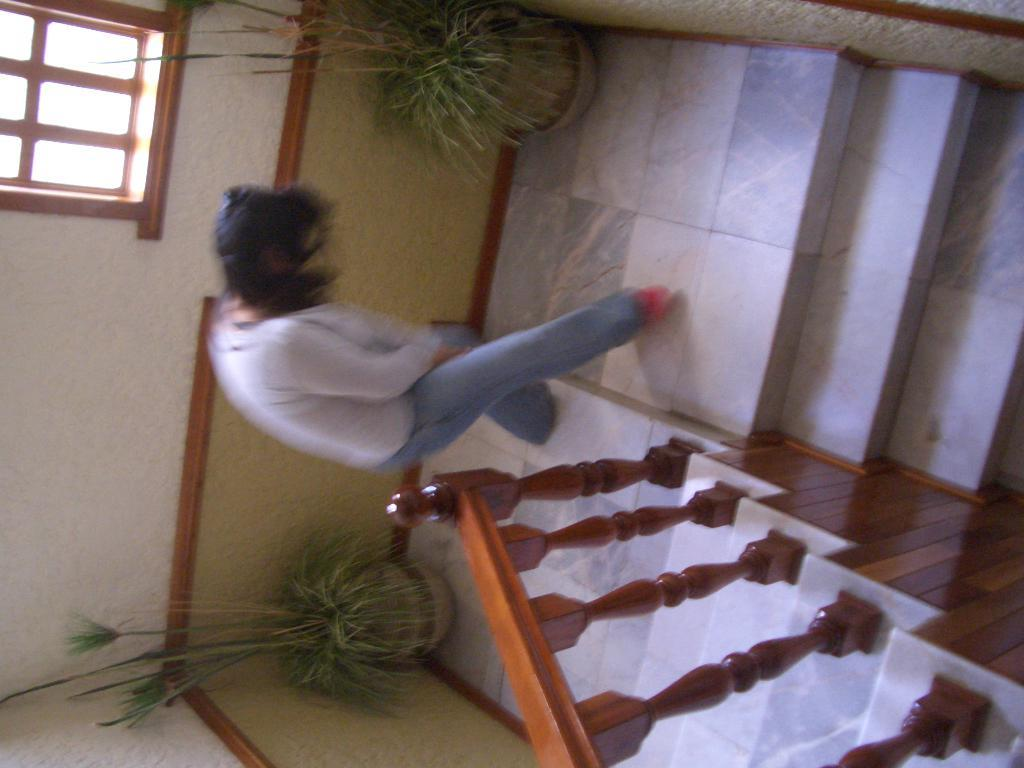Who is present in the image? There is a woman in the image. What is the woman doing in the image? The woman is standing on the floor. What can be seen near the woman in the image? There is a staircase beside the woman, and there are plant pots on either side of her. What type of ship can be seen in the background of the image? There is no ship present in the image; it features a woman standing near a staircase with plant pots on either side. 